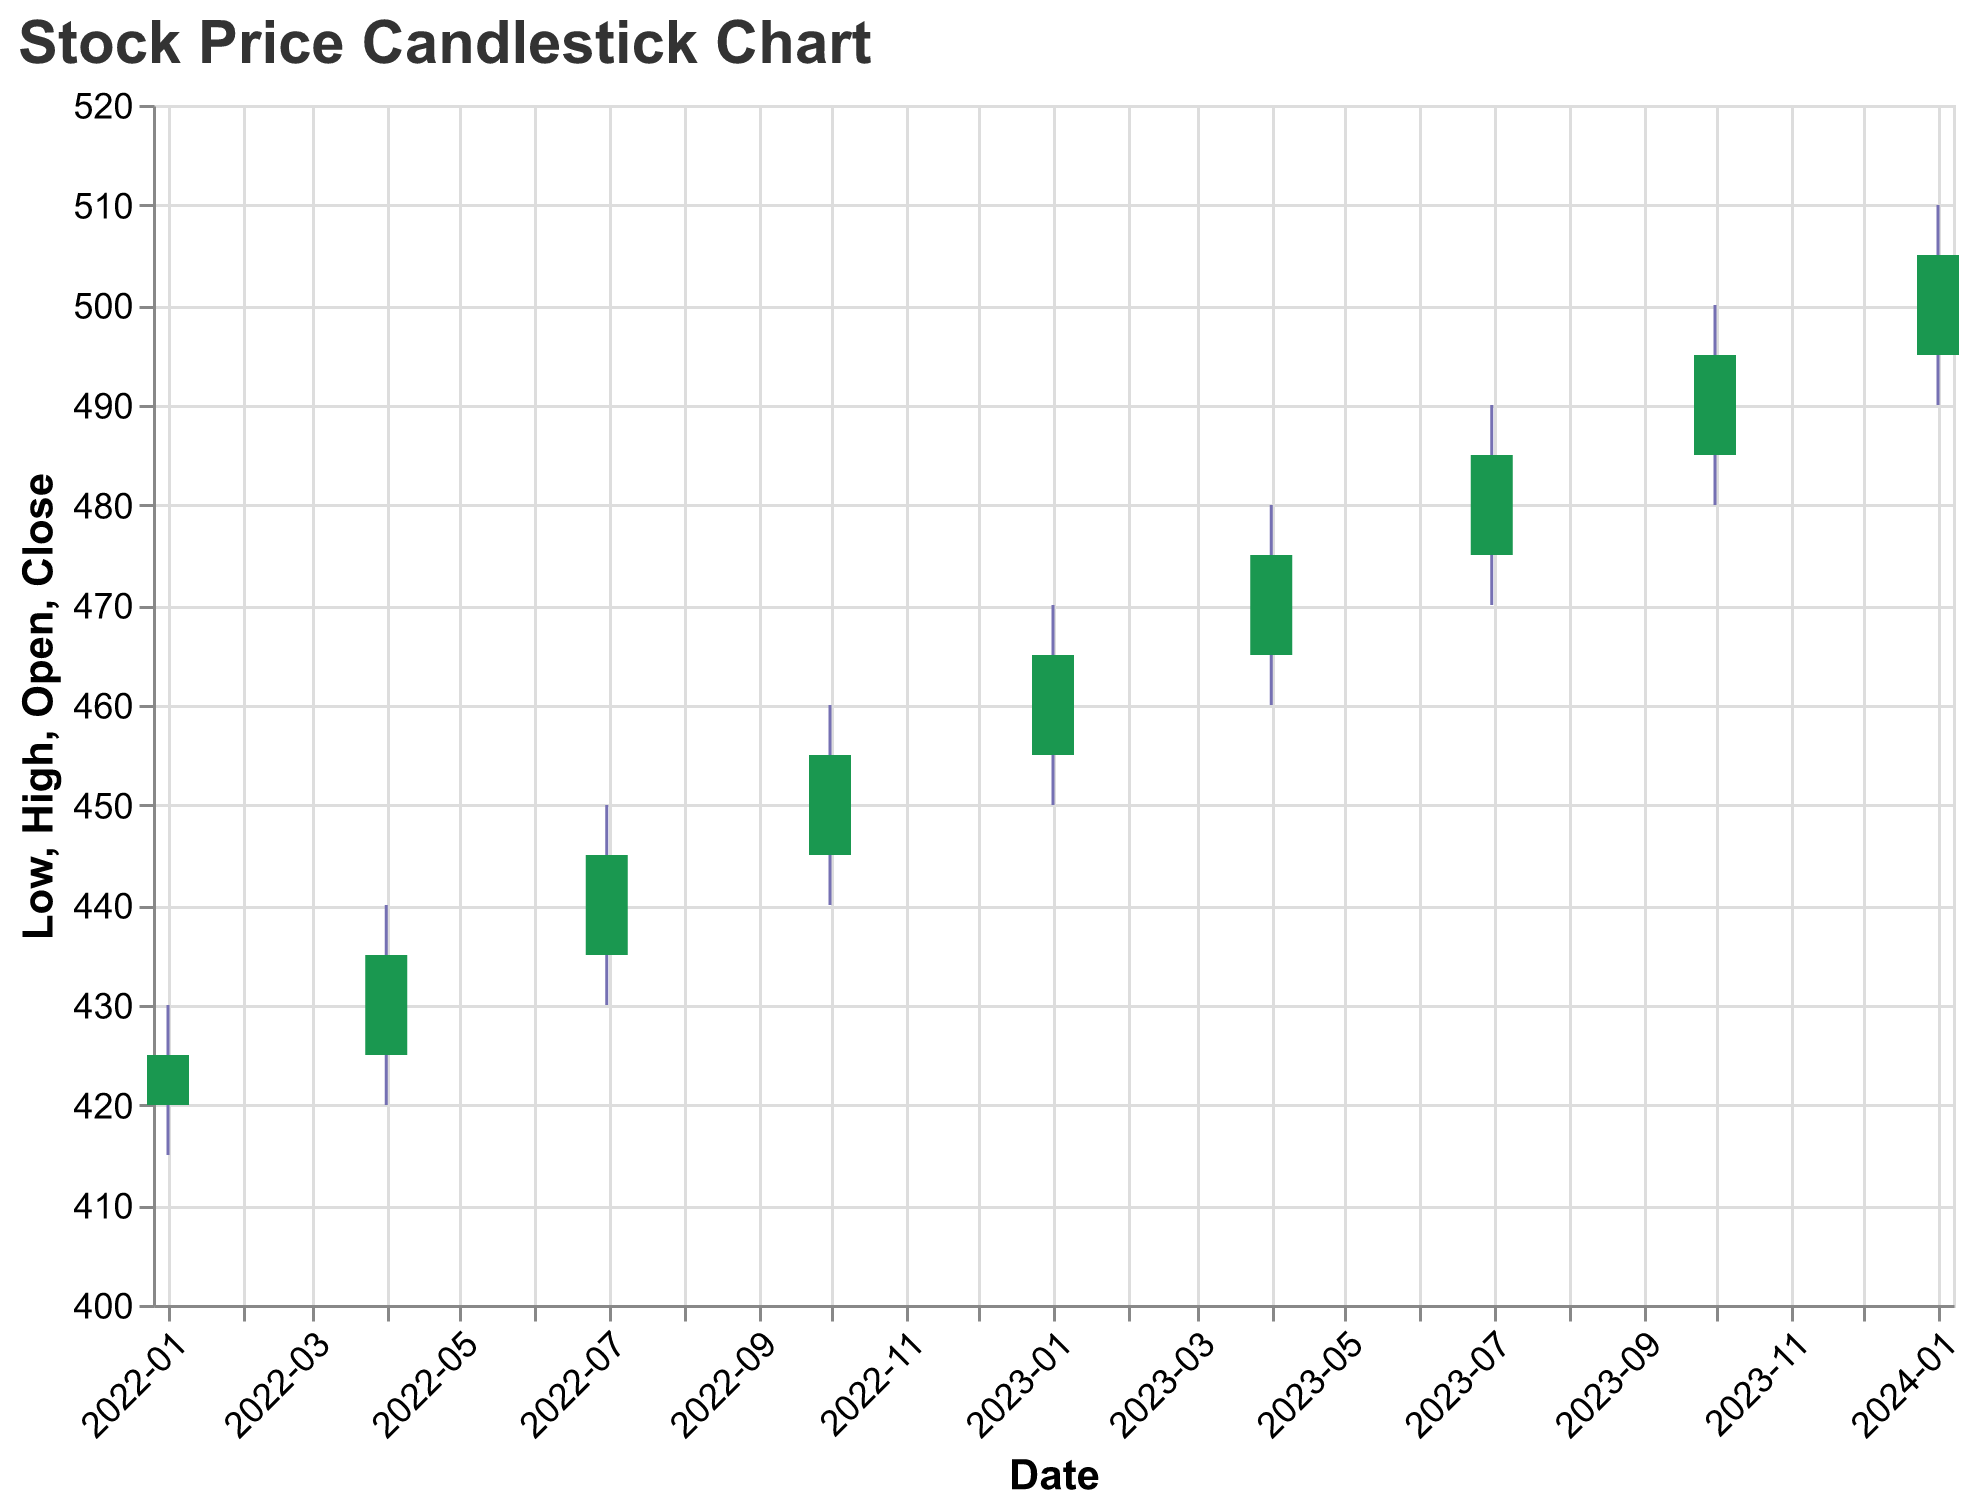How many data points are there in the candlestick chart? There are 9 data points because each date is represented by one candlestick. Count the number of different dates ("Date" field) on the x-axis.
Answer: 9 What does the title of the plot indicate? The title "Stock Price Candlestick Chart" indicates that the plot shows stock price movements over time using candlestick representations.
Answer: Stock Price Candlestick Chart Which data point shows the highest 'Close' price? Look for the tallest green or red bar extending to the highest point. The 'Close' column is at the top of this bar. The highest 'Close' price is on 2024-01-01 with a value of 505.
Answer: 2024-01-01 Which season showed the highest subscriber growth rate for MyService? Compare the "Subscriber_Growth_Rate_MyService" values across all dates. The highest value is 0.13 on 2024-01-01.
Answer: 2024-01-01 Is there any period where our stock price did not increase? Look for red bars, which indicate a decrease in stock prices. There are no red bars in this chart, indicating continuous price increases.
Answer: No How does our 2023-Q1 subscriber growth rate compare to Competitor1's in the same period? Check the values for "Subscriber_Growth_Rate_MyService" and "Subscriber_Growth_Rate_Competitor1" on 2023-01-01. Our rate is 0.09, while Competitor1's rate is 0.08.
Answer: Higher What is the difference between our highest and lowest closing stock prices? Identify the highest 'Close' (505) and the lowest 'Close' (425), then subtract the lowest from the highest: 505 - 425 = 80.
Answer: 80 How has the closing stock price trended over the given period? Observe the 'Close' values from the start to the end. They have consistently increased from 425 to 505.
Answer: Increased Between 2023-04-01 and 2023-07-01, which platform had a higher subscriber growth rate, MyService or Competitor2? Compare the growth rate values on these dates. On 2023-07-01, MyService had 0.11, while Competitor2 had 0.08.
Answer: MyService What is the general trend in subscriber growth rate for Competitor1 during the entire time span? Look at the "Subscriber_Growth_Rate_Competitor1" column from start to end. The values increase consistently from 0.04 to 0.12.
Answer: Increase 